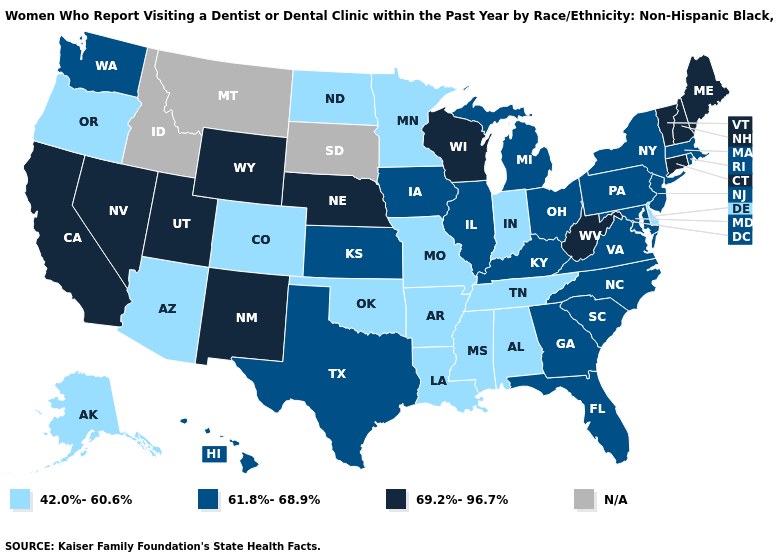Does West Virginia have the highest value in the USA?
Concise answer only. Yes. Name the states that have a value in the range N/A?
Answer briefly. Idaho, Montana, South Dakota. Does Alaska have the highest value in the USA?
Write a very short answer. No. Does the first symbol in the legend represent the smallest category?
Concise answer only. Yes. Among the states that border Washington , which have the highest value?
Write a very short answer. Oregon. Name the states that have a value in the range N/A?
Concise answer only. Idaho, Montana, South Dakota. What is the highest value in the MidWest ?
Answer briefly. 69.2%-96.7%. Name the states that have a value in the range 61.8%-68.9%?
Write a very short answer. Florida, Georgia, Hawaii, Illinois, Iowa, Kansas, Kentucky, Maryland, Massachusetts, Michigan, New Jersey, New York, North Carolina, Ohio, Pennsylvania, Rhode Island, South Carolina, Texas, Virginia, Washington. Name the states that have a value in the range 69.2%-96.7%?
Short answer required. California, Connecticut, Maine, Nebraska, Nevada, New Hampshire, New Mexico, Utah, Vermont, West Virginia, Wisconsin, Wyoming. Name the states that have a value in the range 42.0%-60.6%?
Write a very short answer. Alabama, Alaska, Arizona, Arkansas, Colorado, Delaware, Indiana, Louisiana, Minnesota, Mississippi, Missouri, North Dakota, Oklahoma, Oregon, Tennessee. Name the states that have a value in the range 42.0%-60.6%?
Keep it brief. Alabama, Alaska, Arizona, Arkansas, Colorado, Delaware, Indiana, Louisiana, Minnesota, Mississippi, Missouri, North Dakota, Oklahoma, Oregon, Tennessee. Name the states that have a value in the range 42.0%-60.6%?
Concise answer only. Alabama, Alaska, Arizona, Arkansas, Colorado, Delaware, Indiana, Louisiana, Minnesota, Mississippi, Missouri, North Dakota, Oklahoma, Oregon, Tennessee. How many symbols are there in the legend?
Keep it brief. 4. What is the lowest value in the West?
Keep it brief. 42.0%-60.6%. Name the states that have a value in the range 42.0%-60.6%?
Quick response, please. Alabama, Alaska, Arizona, Arkansas, Colorado, Delaware, Indiana, Louisiana, Minnesota, Mississippi, Missouri, North Dakota, Oklahoma, Oregon, Tennessee. 